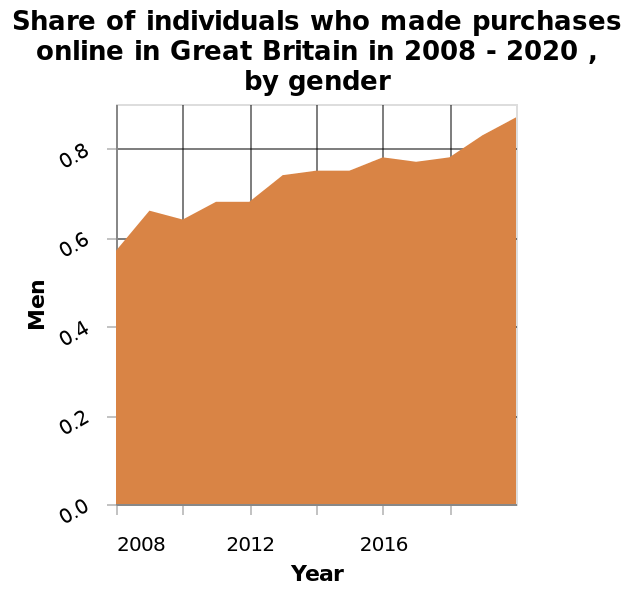<image>
Is there a change in the demographic of online shoppers? Yes, there is an increasing share of men making purchases online. 